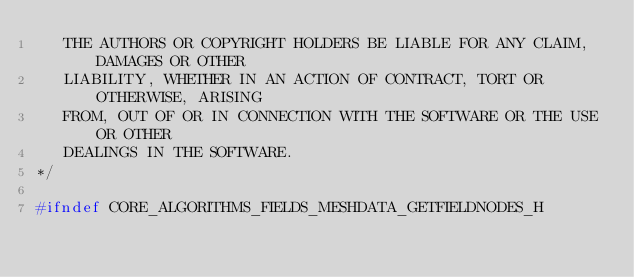<code> <loc_0><loc_0><loc_500><loc_500><_C_>   THE AUTHORS OR COPYRIGHT HOLDERS BE LIABLE FOR ANY CLAIM, DAMAGES OR OTHER
   LIABILITY, WHETHER IN AN ACTION OF CONTRACT, TORT OR OTHERWISE, ARISING
   FROM, OUT OF OR IN CONNECTION WITH THE SOFTWARE OR THE USE OR OTHER
   DEALINGS IN THE SOFTWARE.
*/

#ifndef CORE_ALGORITHMS_FIELDS_MESHDATA_GETFIELDNODES_H</code> 